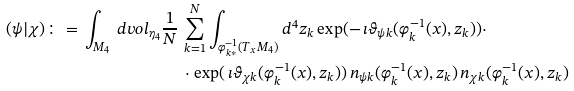Convert formula to latex. <formula><loc_0><loc_0><loc_500><loc_500>( \psi | \chi ) \colon = \, \int _ { M _ { 4 } } \, d v o l _ { { \eta } _ { 4 } } \frac { 1 } { N } \, & \sum ^ { N } _ { k = 1 } \int _ { \varphi ^ { - 1 } _ { k * } ( T _ { x } M _ { 4 } ) } d ^ { 4 } z _ { k } \exp ( - \, \imath \vartheta _ { \psi k } ( \varphi ^ { - 1 } _ { k } ( x ) , z _ { k } ) ) \cdot \\ & \cdot \exp ( \, \imath \vartheta _ { \chi k } ( \varphi ^ { - 1 } _ { k } ( x ) , z _ { k } ) ) \, n _ { \psi k } ( \varphi ^ { - 1 } _ { k } ( x ) , z _ { k } ) \, n _ { \chi k } ( \varphi ^ { - 1 } _ { k } ( x ) , z _ { k } )</formula> 